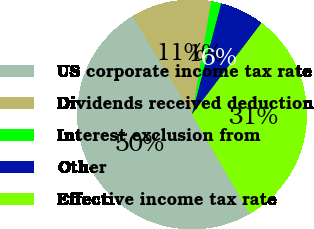Convert chart. <chart><loc_0><loc_0><loc_500><loc_500><pie_chart><fcel>US corporate income tax rate<fcel>Dividends received deduction<fcel>Interest exclusion from<fcel>Other<fcel>Effective income tax rate<nl><fcel>49.72%<fcel>11.36%<fcel>1.42%<fcel>6.25%<fcel>31.25%<nl></chart> 